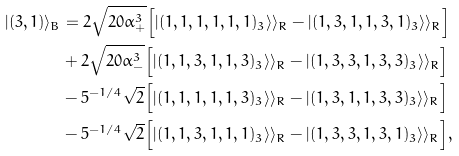Convert formula to latex. <formula><loc_0><loc_0><loc_500><loc_500>| ( 3 , 1 ) \rangle _ { B } & = 2 \sqrt { 2 0 \alpha _ { + } ^ { 3 } } \Big { [ } | ( 1 , 1 , 1 , 1 , 1 , 1 ) _ { 3 } \rangle \rangle _ { R } - | ( 1 , 3 , 1 , 1 , 3 , 1 ) _ { 3 } \rangle \rangle _ { R } \Big { ] } \\ & + 2 \sqrt { 2 0 \alpha _ { - } ^ { 3 } } \Big { [ } | ( 1 , 1 , 3 , 1 , 1 , 3 ) _ { 3 } \rangle \rangle _ { R } - | ( 1 , 3 , 3 , 1 , 3 , 3 ) _ { 3 } \rangle \rangle _ { R } \Big { ] } \\ & - 5 ^ { - 1 / 4 } \sqrt { 2 } \Big { [ } | ( 1 , 1 , 1 , 1 , 1 , 3 ) _ { 3 } \rangle \rangle _ { R } - | ( 1 , 3 , 1 , 1 , 3 , 3 ) _ { 3 } \rangle \rangle _ { R } \Big { ] } \\ & - 5 ^ { - 1 / 4 } \sqrt { 2 } \Big { [ } | ( 1 , 1 , 3 , 1 , 1 , 1 ) _ { 3 } \rangle \rangle _ { R } - | ( 1 , 3 , 3 , 1 , 3 , 1 ) _ { 3 } \rangle \rangle _ { R } \Big { ] } ,</formula> 